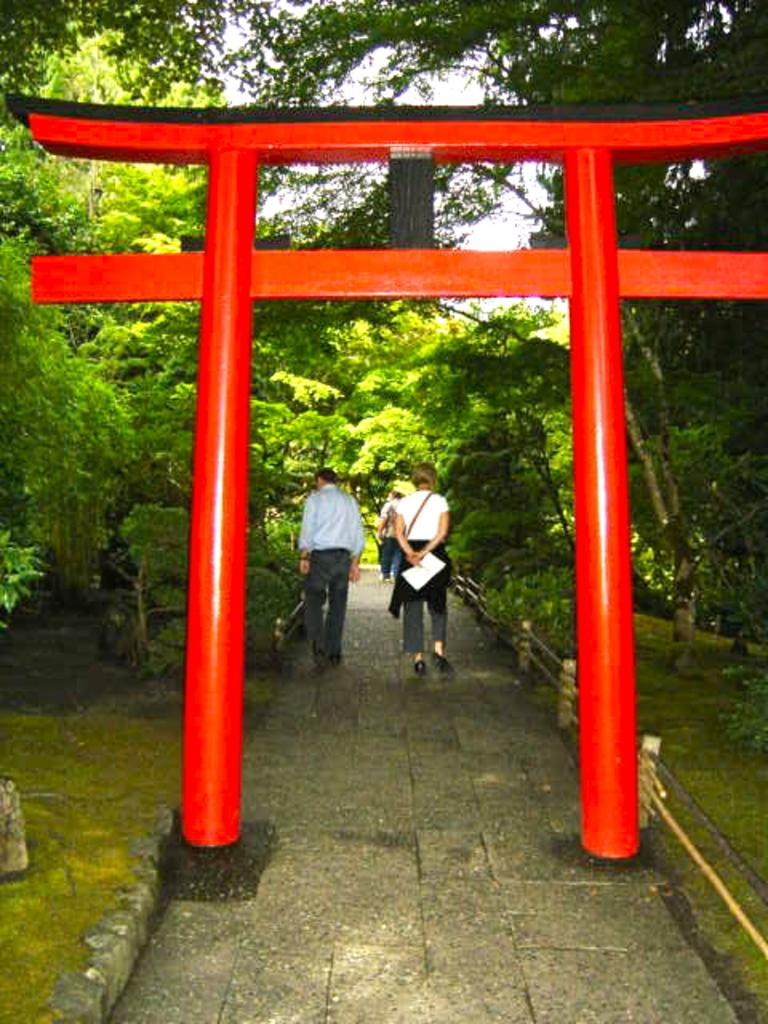What is the main structure visible on the road in the image? There is a red color arch on the road in the image. What can be seen on the arch? There are persons on the arch. What type of vegetation is present on both sides of the arch? There are trees on both sides of the arch. What type of ground cover is present on both sides of the arch? There is grass on the ground on both sides of the arch. What is visible in the background of the image? The sky is visible in the background. How many toes can be seen on the persons standing on the arch? There is no information about the number of toes visible on the persons standing on the arch, as the image does not show their feet. What type of shop is located near the arch? There is no shop visible in the image; it only shows the arch, persons on it, trees, grass, and the sky. 